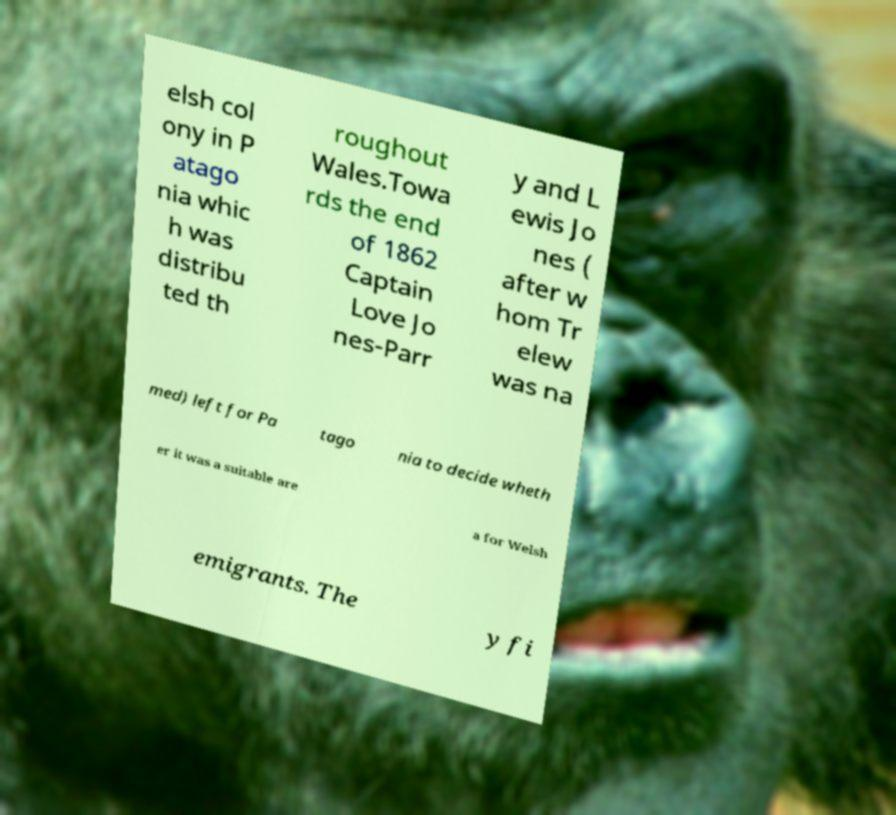For documentation purposes, I need the text within this image transcribed. Could you provide that? elsh col ony in P atago nia whic h was distribu ted th roughout Wales.Towa rds the end of 1862 Captain Love Jo nes-Parr y and L ewis Jo nes ( after w hom Tr elew was na med) left for Pa tago nia to decide wheth er it was a suitable are a for Welsh emigrants. The y fi 